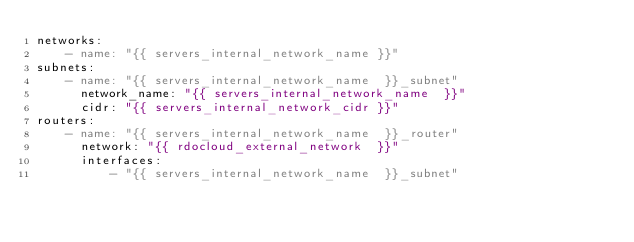Convert code to text. <code><loc_0><loc_0><loc_500><loc_500><_YAML_>networks:
    - name: "{{ servers_internal_network_name }}"
subnets:
    - name: "{{ servers_internal_network_name  }}_subnet"
      network_name: "{{ servers_internal_network_name  }}"
      cidr: "{{ servers_internal_network_cidr }}"
routers:
    - name: "{{ servers_internal_network_name  }}_router"
      network: "{{ rdocloud_external_network  }}"
      interfaces:
          - "{{ servers_internal_network_name  }}_subnet"
</code> 